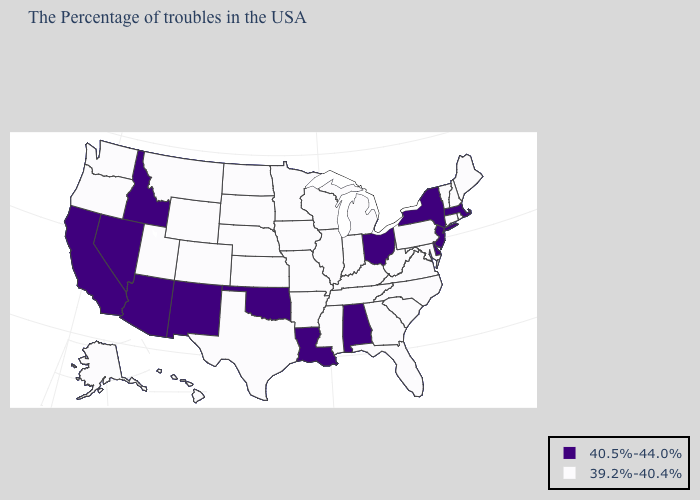What is the highest value in the USA?
Concise answer only. 40.5%-44.0%. Does Georgia have a lower value than California?
Answer briefly. Yes. What is the value of Virginia?
Give a very brief answer. 39.2%-40.4%. Name the states that have a value in the range 40.5%-44.0%?
Concise answer only. Massachusetts, New York, New Jersey, Delaware, Ohio, Alabama, Louisiana, Oklahoma, New Mexico, Arizona, Idaho, Nevada, California. Does New Jersey have the highest value in the USA?
Answer briefly. Yes. Which states hav the highest value in the Northeast?
Short answer required. Massachusetts, New York, New Jersey. Does New Jersey have the highest value in the USA?
Concise answer only. Yes. Name the states that have a value in the range 40.5%-44.0%?
Answer briefly. Massachusetts, New York, New Jersey, Delaware, Ohio, Alabama, Louisiana, Oklahoma, New Mexico, Arizona, Idaho, Nevada, California. What is the lowest value in the West?
Quick response, please. 39.2%-40.4%. What is the value of South Dakota?
Write a very short answer. 39.2%-40.4%. What is the lowest value in the West?
Be succinct. 39.2%-40.4%. Which states hav the highest value in the West?
Short answer required. New Mexico, Arizona, Idaho, Nevada, California. What is the value of Nevada?
Write a very short answer. 40.5%-44.0%. What is the value of Wisconsin?
Write a very short answer. 39.2%-40.4%. What is the value of Rhode Island?
Write a very short answer. 39.2%-40.4%. 